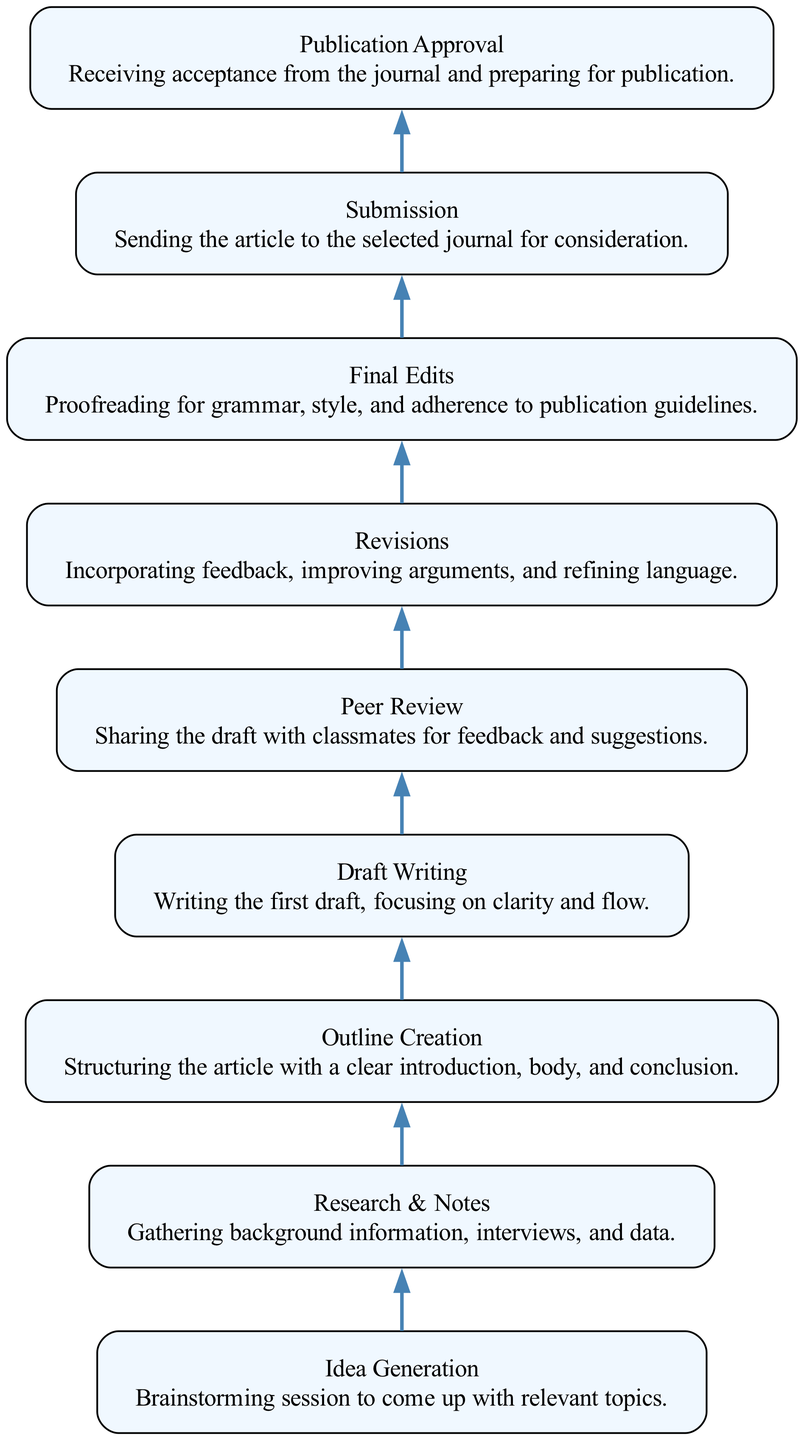What is the first step in the submission process? The diagram starts with the "Idea Generation" node, which indicates the process begins with brainstorming relevant topics.
Answer: Idea Generation How many total steps are there from brainstorming to publication approval? By analyzing the diagram, there are nine distinct steps in the flowchart from "Idea Generation" to "Publication Approval."
Answer: Nine Which step comes immediately after "Draft Writing"? "Peer Review" follows "Draft Writing" in the sequence of the submission process shown in the diagram.
Answer: Peer Review What is the last step before an article is submitted to the journal? The step listed just before "Submission" is "Final Edits," which involves proofreading and ensuring the article meets publication standards.
Answer: Final Edits Which step involves external feedback on the draft? The diagram specifies "Peer Review" as the phase where feedback is gathered from classmates on the draft.
Answer: Peer Review What are the two steps that occur after "Revisions"? The diagram indicates that the steps that follow "Revisions" are "Final Edits" and then "Submission."
Answer: Final Edits, Submission How does "Research & Notes" relate to "Outline Creation"? "Research & Notes" must be completed before "Outline Creation" can occur, as the outline is based on the gathered information.
Answer: Sequentially dependent What is the purpose of the "Publication Approval" step? "Publication Approval" is the final step where acceptance from the journal is received, preparing the article for publication.
Answer: Acceptance from journal Which step emphasizes article structure? "Outline Creation" focuses on structuring the article with elements such as introduction, body, and conclusion.
Answer: Outline Creation 